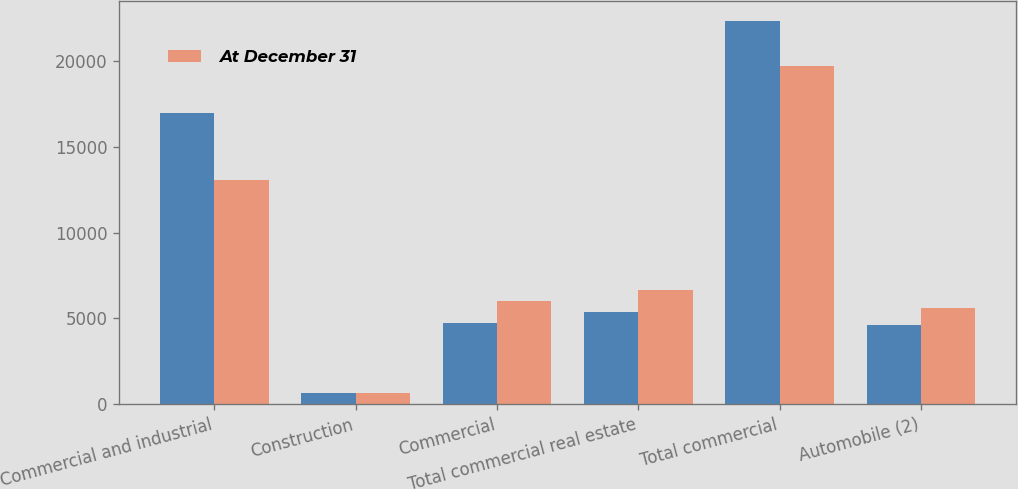<chart> <loc_0><loc_0><loc_500><loc_500><stacked_bar_chart><ecel><fcel>Commercial and industrial<fcel>Construction<fcel>Commercial<fcel>Total commercial real estate<fcel>Total commercial<fcel>Automobile (2)<nl><fcel>nan<fcel>16971<fcel>648<fcel>4751<fcel>5399<fcel>22370<fcel>4634<nl><fcel>At December 31<fcel>13063<fcel>650<fcel>6001<fcel>6651<fcel>19714<fcel>5614<nl></chart> 